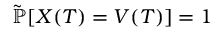<formula> <loc_0><loc_0><loc_500><loc_500>{ \tilde { \mathbb { P } } } [ X ( T ) = V ( T ) ] = 1</formula> 